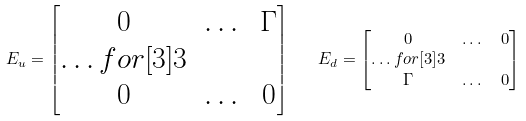<formula> <loc_0><loc_0><loc_500><loc_500>E _ { u } = \begin{bmatrix} 0 & \dots & \Gamma \\ \hdots f o r [ 3 ] { 3 } \\ 0 & \dots & 0 \end{bmatrix} \quad & E _ { d } = \begin{bmatrix} 0 & \dots & 0 \\ \hdots f o r [ 3 ] { 3 } \\ \Gamma & \dots & 0 \end{bmatrix}</formula> 